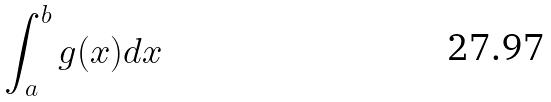<formula> <loc_0><loc_0><loc_500><loc_500>\int _ { a } ^ { b } g ( x ) d x</formula> 